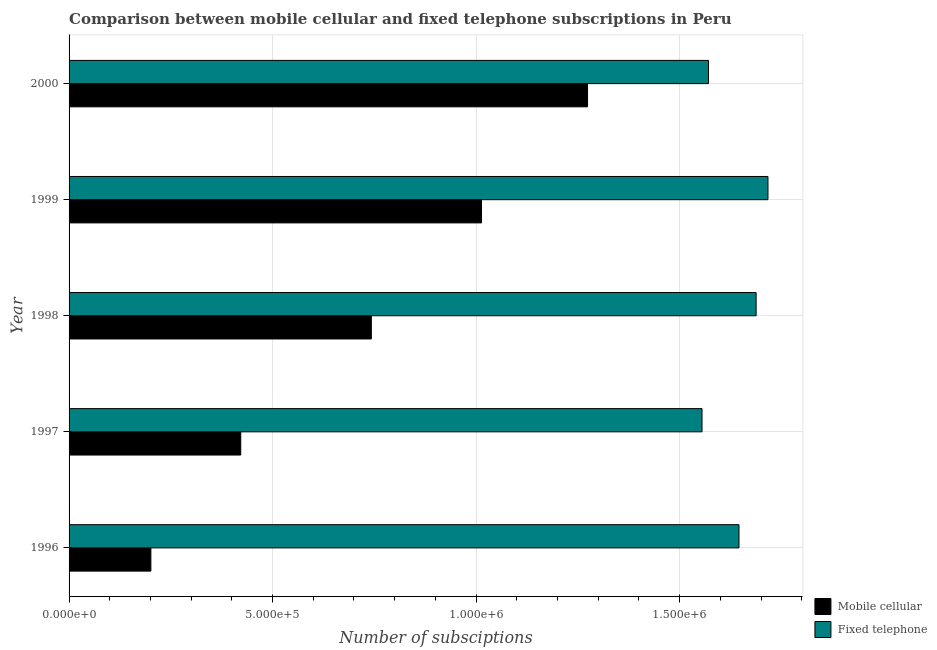How many different coloured bars are there?
Give a very brief answer. 2. Are the number of bars on each tick of the Y-axis equal?
Your answer should be compact. Yes. How many bars are there on the 5th tick from the bottom?
Provide a short and direct response. 2. What is the number of mobile cellular subscriptions in 1997?
Ensure brevity in your answer.  4.22e+05. Across all years, what is the maximum number of mobile cellular subscriptions?
Offer a very short reply. 1.27e+06. Across all years, what is the minimum number of fixed telephone subscriptions?
Provide a short and direct response. 1.56e+06. What is the total number of fixed telephone subscriptions in the graph?
Your answer should be very brief. 8.18e+06. What is the difference between the number of mobile cellular subscriptions in 1997 and that in 1999?
Provide a short and direct response. -5.92e+05. What is the difference between the number of mobile cellular subscriptions in 1998 and the number of fixed telephone subscriptions in 1997?
Your answer should be very brief. -8.12e+05. What is the average number of fixed telephone subscriptions per year?
Your answer should be compact. 1.64e+06. In the year 2000, what is the difference between the number of mobile cellular subscriptions and number of fixed telephone subscriptions?
Keep it short and to the point. -2.97e+05. What is the ratio of the number of mobile cellular subscriptions in 1998 to that in 2000?
Your answer should be very brief. 0.58. Is the difference between the number of fixed telephone subscriptions in 1996 and 1999 greater than the difference between the number of mobile cellular subscriptions in 1996 and 1999?
Your answer should be very brief. Yes. What is the difference between the highest and the second highest number of mobile cellular subscriptions?
Your answer should be very brief. 2.61e+05. What is the difference between the highest and the lowest number of mobile cellular subscriptions?
Offer a very short reply. 1.07e+06. In how many years, is the number of mobile cellular subscriptions greater than the average number of mobile cellular subscriptions taken over all years?
Make the answer very short. 3. What does the 2nd bar from the top in 1998 represents?
Your answer should be very brief. Mobile cellular. What does the 1st bar from the bottom in 1999 represents?
Offer a terse response. Mobile cellular. How many bars are there?
Offer a very short reply. 10. Are all the bars in the graph horizontal?
Keep it short and to the point. Yes. How many years are there in the graph?
Ensure brevity in your answer.  5. Does the graph contain any zero values?
Give a very brief answer. No. How are the legend labels stacked?
Give a very brief answer. Vertical. What is the title of the graph?
Provide a succinct answer. Comparison between mobile cellular and fixed telephone subscriptions in Peru. What is the label or title of the X-axis?
Offer a very short reply. Number of subsciptions. What is the Number of subsciptions in Mobile cellular in 1996?
Provide a short and direct response. 2.01e+05. What is the Number of subsciptions in Fixed telephone in 1996?
Your answer should be very brief. 1.65e+06. What is the Number of subsciptions of Mobile cellular in 1997?
Offer a terse response. 4.22e+05. What is the Number of subsciptions of Fixed telephone in 1997?
Offer a very short reply. 1.56e+06. What is the Number of subsciptions of Mobile cellular in 1998?
Offer a terse response. 7.43e+05. What is the Number of subsciptions in Fixed telephone in 1998?
Make the answer very short. 1.69e+06. What is the Number of subsciptions of Mobile cellular in 1999?
Offer a very short reply. 1.01e+06. What is the Number of subsciptions of Fixed telephone in 1999?
Offer a very short reply. 1.72e+06. What is the Number of subsciptions in Mobile cellular in 2000?
Offer a very short reply. 1.27e+06. What is the Number of subsciptions of Fixed telephone in 2000?
Offer a terse response. 1.57e+06. Across all years, what is the maximum Number of subsciptions of Mobile cellular?
Your response must be concise. 1.27e+06. Across all years, what is the maximum Number of subsciptions in Fixed telephone?
Provide a succinct answer. 1.72e+06. Across all years, what is the minimum Number of subsciptions of Mobile cellular?
Offer a terse response. 2.01e+05. Across all years, what is the minimum Number of subsciptions in Fixed telephone?
Offer a very short reply. 1.56e+06. What is the total Number of subsciptions of Mobile cellular in the graph?
Keep it short and to the point. 3.65e+06. What is the total Number of subsciptions of Fixed telephone in the graph?
Offer a terse response. 8.18e+06. What is the difference between the Number of subsciptions in Mobile cellular in 1996 and that in 1997?
Offer a terse response. -2.21e+05. What is the difference between the Number of subsciptions in Fixed telephone in 1996 and that in 1997?
Make the answer very short. 9.08e+04. What is the difference between the Number of subsciptions in Mobile cellular in 1996 and that in 1998?
Give a very brief answer. -5.42e+05. What is the difference between the Number of subsciptions in Fixed telephone in 1996 and that in 1998?
Give a very brief answer. -4.21e+04. What is the difference between the Number of subsciptions of Mobile cellular in 1996 and that in 1999?
Ensure brevity in your answer.  -8.12e+05. What is the difference between the Number of subsciptions of Fixed telephone in 1996 and that in 1999?
Give a very brief answer. -7.12e+04. What is the difference between the Number of subsciptions in Mobile cellular in 1996 and that in 2000?
Give a very brief answer. -1.07e+06. What is the difference between the Number of subsciptions in Fixed telephone in 1996 and that in 2000?
Your answer should be very brief. 7.50e+04. What is the difference between the Number of subsciptions in Mobile cellular in 1997 and that in 1998?
Give a very brief answer. -3.21e+05. What is the difference between the Number of subsciptions of Fixed telephone in 1997 and that in 1998?
Provide a short and direct response. -1.33e+05. What is the difference between the Number of subsciptions in Mobile cellular in 1997 and that in 1999?
Ensure brevity in your answer.  -5.92e+05. What is the difference between the Number of subsciptions of Fixed telephone in 1997 and that in 1999?
Your answer should be compact. -1.62e+05. What is the difference between the Number of subsciptions of Mobile cellular in 1997 and that in 2000?
Ensure brevity in your answer.  -8.52e+05. What is the difference between the Number of subsciptions in Fixed telephone in 1997 and that in 2000?
Your answer should be compact. -1.59e+04. What is the difference between the Number of subsciptions in Mobile cellular in 1998 and that in 1999?
Provide a short and direct response. -2.71e+05. What is the difference between the Number of subsciptions of Fixed telephone in 1998 and that in 1999?
Your answer should be very brief. -2.91e+04. What is the difference between the Number of subsciptions of Mobile cellular in 1998 and that in 2000?
Offer a terse response. -5.31e+05. What is the difference between the Number of subsciptions of Fixed telephone in 1998 and that in 2000?
Make the answer very short. 1.17e+05. What is the difference between the Number of subsciptions in Mobile cellular in 1999 and that in 2000?
Offer a terse response. -2.61e+05. What is the difference between the Number of subsciptions in Fixed telephone in 1999 and that in 2000?
Offer a terse response. 1.46e+05. What is the difference between the Number of subsciptions in Mobile cellular in 1996 and the Number of subsciptions in Fixed telephone in 1997?
Make the answer very short. -1.35e+06. What is the difference between the Number of subsciptions in Mobile cellular in 1996 and the Number of subsciptions in Fixed telephone in 1998?
Your answer should be compact. -1.49e+06. What is the difference between the Number of subsciptions of Mobile cellular in 1996 and the Number of subsciptions of Fixed telephone in 1999?
Provide a short and direct response. -1.52e+06. What is the difference between the Number of subsciptions of Mobile cellular in 1996 and the Number of subsciptions of Fixed telephone in 2000?
Your response must be concise. -1.37e+06. What is the difference between the Number of subsciptions in Mobile cellular in 1997 and the Number of subsciptions in Fixed telephone in 1998?
Your response must be concise. -1.27e+06. What is the difference between the Number of subsciptions of Mobile cellular in 1997 and the Number of subsciptions of Fixed telephone in 1999?
Make the answer very short. -1.30e+06. What is the difference between the Number of subsciptions of Mobile cellular in 1997 and the Number of subsciptions of Fixed telephone in 2000?
Your answer should be very brief. -1.15e+06. What is the difference between the Number of subsciptions in Mobile cellular in 1998 and the Number of subsciptions in Fixed telephone in 1999?
Provide a short and direct response. -9.74e+05. What is the difference between the Number of subsciptions in Mobile cellular in 1998 and the Number of subsciptions in Fixed telephone in 2000?
Offer a very short reply. -8.28e+05. What is the difference between the Number of subsciptions of Mobile cellular in 1999 and the Number of subsciptions of Fixed telephone in 2000?
Offer a terse response. -5.58e+05. What is the average Number of subsciptions of Mobile cellular per year?
Keep it short and to the point. 7.31e+05. What is the average Number of subsciptions in Fixed telephone per year?
Make the answer very short. 1.64e+06. In the year 1996, what is the difference between the Number of subsciptions in Mobile cellular and Number of subsciptions in Fixed telephone?
Offer a terse response. -1.44e+06. In the year 1997, what is the difference between the Number of subsciptions of Mobile cellular and Number of subsciptions of Fixed telephone?
Your response must be concise. -1.13e+06. In the year 1998, what is the difference between the Number of subsciptions of Mobile cellular and Number of subsciptions of Fixed telephone?
Offer a very short reply. -9.45e+05. In the year 1999, what is the difference between the Number of subsciptions of Mobile cellular and Number of subsciptions of Fixed telephone?
Provide a short and direct response. -7.04e+05. In the year 2000, what is the difference between the Number of subsciptions in Mobile cellular and Number of subsciptions in Fixed telephone?
Provide a short and direct response. -2.97e+05. What is the ratio of the Number of subsciptions of Mobile cellular in 1996 to that in 1997?
Keep it short and to the point. 0.48. What is the ratio of the Number of subsciptions in Fixed telephone in 1996 to that in 1997?
Provide a short and direct response. 1.06. What is the ratio of the Number of subsciptions in Mobile cellular in 1996 to that in 1998?
Provide a short and direct response. 0.27. What is the ratio of the Number of subsciptions in Fixed telephone in 1996 to that in 1998?
Provide a succinct answer. 0.98. What is the ratio of the Number of subsciptions of Mobile cellular in 1996 to that in 1999?
Ensure brevity in your answer.  0.2. What is the ratio of the Number of subsciptions in Fixed telephone in 1996 to that in 1999?
Keep it short and to the point. 0.96. What is the ratio of the Number of subsciptions of Mobile cellular in 1996 to that in 2000?
Your response must be concise. 0.16. What is the ratio of the Number of subsciptions in Fixed telephone in 1996 to that in 2000?
Make the answer very short. 1.05. What is the ratio of the Number of subsciptions in Mobile cellular in 1997 to that in 1998?
Provide a succinct answer. 0.57. What is the ratio of the Number of subsciptions in Fixed telephone in 1997 to that in 1998?
Your answer should be very brief. 0.92. What is the ratio of the Number of subsciptions in Mobile cellular in 1997 to that in 1999?
Your response must be concise. 0.42. What is the ratio of the Number of subsciptions in Fixed telephone in 1997 to that in 1999?
Keep it short and to the point. 0.91. What is the ratio of the Number of subsciptions in Mobile cellular in 1997 to that in 2000?
Provide a succinct answer. 0.33. What is the ratio of the Number of subsciptions of Fixed telephone in 1997 to that in 2000?
Offer a terse response. 0.99. What is the ratio of the Number of subsciptions in Mobile cellular in 1998 to that in 1999?
Provide a succinct answer. 0.73. What is the ratio of the Number of subsciptions of Mobile cellular in 1998 to that in 2000?
Offer a very short reply. 0.58. What is the ratio of the Number of subsciptions in Fixed telephone in 1998 to that in 2000?
Provide a short and direct response. 1.07. What is the ratio of the Number of subsciptions of Mobile cellular in 1999 to that in 2000?
Offer a terse response. 0.8. What is the ratio of the Number of subsciptions of Fixed telephone in 1999 to that in 2000?
Your answer should be compact. 1.09. What is the difference between the highest and the second highest Number of subsciptions in Mobile cellular?
Ensure brevity in your answer.  2.61e+05. What is the difference between the highest and the second highest Number of subsciptions of Fixed telephone?
Ensure brevity in your answer.  2.91e+04. What is the difference between the highest and the lowest Number of subsciptions in Mobile cellular?
Provide a short and direct response. 1.07e+06. What is the difference between the highest and the lowest Number of subsciptions of Fixed telephone?
Give a very brief answer. 1.62e+05. 